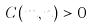Convert formula to latex. <formula><loc_0><loc_0><loc_500><loc_500>C ( m , n ) > 0</formula> 